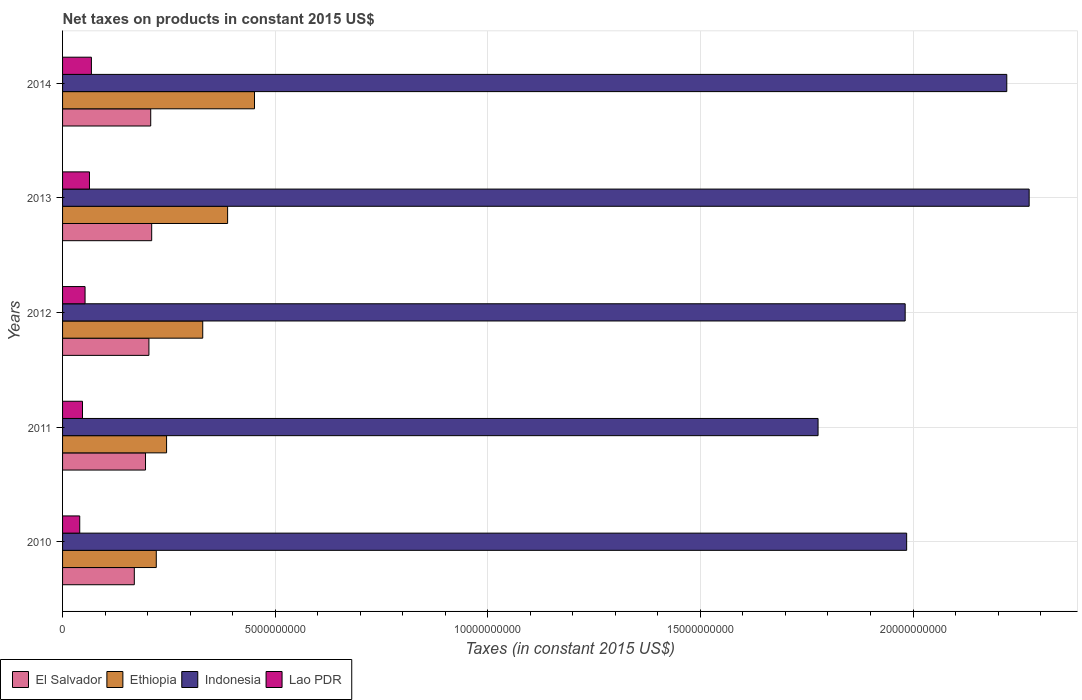How many different coloured bars are there?
Ensure brevity in your answer.  4. Are the number of bars per tick equal to the number of legend labels?
Keep it short and to the point. Yes. In how many cases, is the number of bars for a given year not equal to the number of legend labels?
Your response must be concise. 0. What is the net taxes on products in Indonesia in 2012?
Make the answer very short. 1.98e+1. Across all years, what is the maximum net taxes on products in El Salvador?
Ensure brevity in your answer.  2.10e+09. Across all years, what is the minimum net taxes on products in Lao PDR?
Your response must be concise. 4.04e+08. In which year was the net taxes on products in Indonesia maximum?
Your answer should be compact. 2013. In which year was the net taxes on products in Indonesia minimum?
Make the answer very short. 2011. What is the total net taxes on products in Lao PDR in the graph?
Keep it short and to the point. 2.71e+09. What is the difference between the net taxes on products in Lao PDR in 2010 and that in 2013?
Provide a short and direct response. -2.29e+08. What is the difference between the net taxes on products in El Salvador in 2011 and the net taxes on products in Ethiopia in 2013?
Ensure brevity in your answer.  -1.93e+09. What is the average net taxes on products in Ethiopia per year?
Ensure brevity in your answer.  3.27e+09. In the year 2010, what is the difference between the net taxes on products in Ethiopia and net taxes on products in Lao PDR?
Provide a short and direct response. 1.80e+09. In how many years, is the net taxes on products in Indonesia greater than 14000000000 US$?
Your response must be concise. 5. What is the ratio of the net taxes on products in El Salvador in 2011 to that in 2013?
Give a very brief answer. 0.93. What is the difference between the highest and the second highest net taxes on products in Indonesia?
Your answer should be very brief. 5.26e+08. What is the difference between the highest and the lowest net taxes on products in Ethiopia?
Provide a short and direct response. 2.31e+09. In how many years, is the net taxes on products in Lao PDR greater than the average net taxes on products in Lao PDR taken over all years?
Make the answer very short. 2. Is it the case that in every year, the sum of the net taxes on products in Ethiopia and net taxes on products in Indonesia is greater than the sum of net taxes on products in Lao PDR and net taxes on products in El Salvador?
Give a very brief answer. Yes. What does the 1st bar from the top in 2012 represents?
Ensure brevity in your answer.  Lao PDR. What does the 4th bar from the bottom in 2010 represents?
Provide a short and direct response. Lao PDR. Is it the case that in every year, the sum of the net taxes on products in Ethiopia and net taxes on products in Indonesia is greater than the net taxes on products in Lao PDR?
Provide a short and direct response. Yes. How many years are there in the graph?
Your answer should be compact. 5. Are the values on the major ticks of X-axis written in scientific E-notation?
Offer a very short reply. No. Does the graph contain grids?
Your answer should be compact. Yes. How many legend labels are there?
Provide a short and direct response. 4. What is the title of the graph?
Your answer should be very brief. Net taxes on products in constant 2015 US$. Does "Equatorial Guinea" appear as one of the legend labels in the graph?
Offer a terse response. No. What is the label or title of the X-axis?
Provide a short and direct response. Taxes (in constant 2015 US$). What is the label or title of the Y-axis?
Offer a very short reply. Years. What is the Taxes (in constant 2015 US$) of El Salvador in 2010?
Make the answer very short. 1.69e+09. What is the Taxes (in constant 2015 US$) in Ethiopia in 2010?
Make the answer very short. 2.20e+09. What is the Taxes (in constant 2015 US$) in Indonesia in 2010?
Provide a short and direct response. 1.99e+1. What is the Taxes (in constant 2015 US$) in Lao PDR in 2010?
Your answer should be compact. 4.04e+08. What is the Taxes (in constant 2015 US$) in El Salvador in 2011?
Your answer should be very brief. 1.95e+09. What is the Taxes (in constant 2015 US$) of Ethiopia in 2011?
Provide a succinct answer. 2.45e+09. What is the Taxes (in constant 2015 US$) of Indonesia in 2011?
Make the answer very short. 1.78e+1. What is the Taxes (in constant 2015 US$) of Lao PDR in 2011?
Your response must be concise. 4.69e+08. What is the Taxes (in constant 2015 US$) of El Salvador in 2012?
Provide a succinct answer. 2.03e+09. What is the Taxes (in constant 2015 US$) in Ethiopia in 2012?
Keep it short and to the point. 3.30e+09. What is the Taxes (in constant 2015 US$) of Indonesia in 2012?
Keep it short and to the point. 1.98e+1. What is the Taxes (in constant 2015 US$) in Lao PDR in 2012?
Offer a terse response. 5.29e+08. What is the Taxes (in constant 2015 US$) in El Salvador in 2013?
Make the answer very short. 2.10e+09. What is the Taxes (in constant 2015 US$) in Ethiopia in 2013?
Offer a very short reply. 3.88e+09. What is the Taxes (in constant 2015 US$) of Indonesia in 2013?
Provide a short and direct response. 2.27e+1. What is the Taxes (in constant 2015 US$) in Lao PDR in 2013?
Provide a short and direct response. 6.33e+08. What is the Taxes (in constant 2015 US$) of El Salvador in 2014?
Keep it short and to the point. 2.07e+09. What is the Taxes (in constant 2015 US$) of Ethiopia in 2014?
Offer a terse response. 4.51e+09. What is the Taxes (in constant 2015 US$) of Indonesia in 2014?
Your answer should be compact. 2.22e+1. What is the Taxes (in constant 2015 US$) in Lao PDR in 2014?
Ensure brevity in your answer.  6.78e+08. Across all years, what is the maximum Taxes (in constant 2015 US$) in El Salvador?
Provide a short and direct response. 2.10e+09. Across all years, what is the maximum Taxes (in constant 2015 US$) of Ethiopia?
Provide a short and direct response. 4.51e+09. Across all years, what is the maximum Taxes (in constant 2015 US$) in Indonesia?
Your answer should be very brief. 2.27e+1. Across all years, what is the maximum Taxes (in constant 2015 US$) in Lao PDR?
Offer a very short reply. 6.78e+08. Across all years, what is the minimum Taxes (in constant 2015 US$) in El Salvador?
Keep it short and to the point. 1.69e+09. Across all years, what is the minimum Taxes (in constant 2015 US$) of Ethiopia?
Provide a short and direct response. 2.20e+09. Across all years, what is the minimum Taxes (in constant 2015 US$) in Indonesia?
Ensure brevity in your answer.  1.78e+1. Across all years, what is the minimum Taxes (in constant 2015 US$) in Lao PDR?
Offer a very short reply. 4.04e+08. What is the total Taxes (in constant 2015 US$) of El Salvador in the graph?
Provide a short and direct response. 9.84e+09. What is the total Taxes (in constant 2015 US$) in Ethiopia in the graph?
Offer a very short reply. 1.63e+1. What is the total Taxes (in constant 2015 US$) in Indonesia in the graph?
Your response must be concise. 1.02e+11. What is the total Taxes (in constant 2015 US$) of Lao PDR in the graph?
Your answer should be compact. 2.71e+09. What is the difference between the Taxes (in constant 2015 US$) in El Salvador in 2010 and that in 2011?
Your response must be concise. -2.64e+08. What is the difference between the Taxes (in constant 2015 US$) of Ethiopia in 2010 and that in 2011?
Your answer should be very brief. -2.42e+08. What is the difference between the Taxes (in constant 2015 US$) in Indonesia in 2010 and that in 2011?
Provide a short and direct response. 2.08e+09. What is the difference between the Taxes (in constant 2015 US$) of Lao PDR in 2010 and that in 2011?
Provide a short and direct response. -6.51e+07. What is the difference between the Taxes (in constant 2015 US$) of El Salvador in 2010 and that in 2012?
Ensure brevity in your answer.  -3.44e+08. What is the difference between the Taxes (in constant 2015 US$) in Ethiopia in 2010 and that in 2012?
Offer a very short reply. -1.09e+09. What is the difference between the Taxes (in constant 2015 US$) of Indonesia in 2010 and that in 2012?
Ensure brevity in your answer.  3.49e+07. What is the difference between the Taxes (in constant 2015 US$) in Lao PDR in 2010 and that in 2012?
Your answer should be very brief. -1.25e+08. What is the difference between the Taxes (in constant 2015 US$) in El Salvador in 2010 and that in 2013?
Provide a succinct answer. -4.09e+08. What is the difference between the Taxes (in constant 2015 US$) of Ethiopia in 2010 and that in 2013?
Make the answer very short. -1.68e+09. What is the difference between the Taxes (in constant 2015 US$) in Indonesia in 2010 and that in 2013?
Ensure brevity in your answer.  -2.88e+09. What is the difference between the Taxes (in constant 2015 US$) in Lao PDR in 2010 and that in 2013?
Make the answer very short. -2.29e+08. What is the difference between the Taxes (in constant 2015 US$) of El Salvador in 2010 and that in 2014?
Provide a succinct answer. -3.86e+08. What is the difference between the Taxes (in constant 2015 US$) in Ethiopia in 2010 and that in 2014?
Make the answer very short. -2.31e+09. What is the difference between the Taxes (in constant 2015 US$) of Indonesia in 2010 and that in 2014?
Offer a very short reply. -2.35e+09. What is the difference between the Taxes (in constant 2015 US$) of Lao PDR in 2010 and that in 2014?
Give a very brief answer. -2.74e+08. What is the difference between the Taxes (in constant 2015 US$) of El Salvador in 2011 and that in 2012?
Offer a terse response. -8.00e+07. What is the difference between the Taxes (in constant 2015 US$) in Ethiopia in 2011 and that in 2012?
Give a very brief answer. -8.50e+08. What is the difference between the Taxes (in constant 2015 US$) of Indonesia in 2011 and that in 2012?
Offer a terse response. -2.05e+09. What is the difference between the Taxes (in constant 2015 US$) of Lao PDR in 2011 and that in 2012?
Your answer should be compact. -6.02e+07. What is the difference between the Taxes (in constant 2015 US$) in El Salvador in 2011 and that in 2013?
Make the answer very short. -1.45e+08. What is the difference between the Taxes (in constant 2015 US$) of Ethiopia in 2011 and that in 2013?
Provide a succinct answer. -1.44e+09. What is the difference between the Taxes (in constant 2015 US$) of Indonesia in 2011 and that in 2013?
Provide a succinct answer. -4.96e+09. What is the difference between the Taxes (in constant 2015 US$) of Lao PDR in 2011 and that in 2013?
Offer a very short reply. -1.64e+08. What is the difference between the Taxes (in constant 2015 US$) in El Salvador in 2011 and that in 2014?
Provide a succinct answer. -1.23e+08. What is the difference between the Taxes (in constant 2015 US$) of Ethiopia in 2011 and that in 2014?
Provide a succinct answer. -2.07e+09. What is the difference between the Taxes (in constant 2015 US$) in Indonesia in 2011 and that in 2014?
Make the answer very short. -4.44e+09. What is the difference between the Taxes (in constant 2015 US$) in Lao PDR in 2011 and that in 2014?
Offer a terse response. -2.09e+08. What is the difference between the Taxes (in constant 2015 US$) of El Salvador in 2012 and that in 2013?
Your answer should be very brief. -6.53e+07. What is the difference between the Taxes (in constant 2015 US$) in Ethiopia in 2012 and that in 2013?
Keep it short and to the point. -5.85e+08. What is the difference between the Taxes (in constant 2015 US$) in Indonesia in 2012 and that in 2013?
Make the answer very short. -2.92e+09. What is the difference between the Taxes (in constant 2015 US$) in Lao PDR in 2012 and that in 2013?
Ensure brevity in your answer.  -1.04e+08. What is the difference between the Taxes (in constant 2015 US$) of El Salvador in 2012 and that in 2014?
Offer a very short reply. -4.26e+07. What is the difference between the Taxes (in constant 2015 US$) in Ethiopia in 2012 and that in 2014?
Provide a succinct answer. -1.22e+09. What is the difference between the Taxes (in constant 2015 US$) in Indonesia in 2012 and that in 2014?
Offer a terse response. -2.39e+09. What is the difference between the Taxes (in constant 2015 US$) of Lao PDR in 2012 and that in 2014?
Ensure brevity in your answer.  -1.49e+08. What is the difference between the Taxes (in constant 2015 US$) of El Salvador in 2013 and that in 2014?
Offer a terse response. 2.27e+07. What is the difference between the Taxes (in constant 2015 US$) of Ethiopia in 2013 and that in 2014?
Give a very brief answer. -6.32e+08. What is the difference between the Taxes (in constant 2015 US$) of Indonesia in 2013 and that in 2014?
Offer a terse response. 5.26e+08. What is the difference between the Taxes (in constant 2015 US$) in Lao PDR in 2013 and that in 2014?
Offer a terse response. -4.55e+07. What is the difference between the Taxes (in constant 2015 US$) in El Salvador in 2010 and the Taxes (in constant 2015 US$) in Ethiopia in 2011?
Provide a succinct answer. -7.59e+08. What is the difference between the Taxes (in constant 2015 US$) in El Salvador in 2010 and the Taxes (in constant 2015 US$) in Indonesia in 2011?
Provide a succinct answer. -1.61e+1. What is the difference between the Taxes (in constant 2015 US$) of El Salvador in 2010 and the Taxes (in constant 2015 US$) of Lao PDR in 2011?
Offer a very short reply. 1.22e+09. What is the difference between the Taxes (in constant 2015 US$) of Ethiopia in 2010 and the Taxes (in constant 2015 US$) of Indonesia in 2011?
Give a very brief answer. -1.56e+1. What is the difference between the Taxes (in constant 2015 US$) of Ethiopia in 2010 and the Taxes (in constant 2015 US$) of Lao PDR in 2011?
Your answer should be very brief. 1.74e+09. What is the difference between the Taxes (in constant 2015 US$) of Indonesia in 2010 and the Taxes (in constant 2015 US$) of Lao PDR in 2011?
Your answer should be compact. 1.94e+1. What is the difference between the Taxes (in constant 2015 US$) in El Salvador in 2010 and the Taxes (in constant 2015 US$) in Ethiopia in 2012?
Offer a terse response. -1.61e+09. What is the difference between the Taxes (in constant 2015 US$) of El Salvador in 2010 and the Taxes (in constant 2015 US$) of Indonesia in 2012?
Give a very brief answer. -1.81e+1. What is the difference between the Taxes (in constant 2015 US$) in El Salvador in 2010 and the Taxes (in constant 2015 US$) in Lao PDR in 2012?
Provide a succinct answer. 1.16e+09. What is the difference between the Taxes (in constant 2015 US$) of Ethiopia in 2010 and the Taxes (in constant 2015 US$) of Indonesia in 2012?
Your answer should be very brief. -1.76e+1. What is the difference between the Taxes (in constant 2015 US$) of Ethiopia in 2010 and the Taxes (in constant 2015 US$) of Lao PDR in 2012?
Provide a short and direct response. 1.67e+09. What is the difference between the Taxes (in constant 2015 US$) in Indonesia in 2010 and the Taxes (in constant 2015 US$) in Lao PDR in 2012?
Your answer should be compact. 1.93e+1. What is the difference between the Taxes (in constant 2015 US$) of El Salvador in 2010 and the Taxes (in constant 2015 US$) of Ethiopia in 2013?
Offer a terse response. -2.19e+09. What is the difference between the Taxes (in constant 2015 US$) of El Salvador in 2010 and the Taxes (in constant 2015 US$) of Indonesia in 2013?
Your response must be concise. -2.10e+1. What is the difference between the Taxes (in constant 2015 US$) of El Salvador in 2010 and the Taxes (in constant 2015 US$) of Lao PDR in 2013?
Provide a succinct answer. 1.05e+09. What is the difference between the Taxes (in constant 2015 US$) in Ethiopia in 2010 and the Taxes (in constant 2015 US$) in Indonesia in 2013?
Make the answer very short. -2.05e+1. What is the difference between the Taxes (in constant 2015 US$) of Ethiopia in 2010 and the Taxes (in constant 2015 US$) of Lao PDR in 2013?
Offer a terse response. 1.57e+09. What is the difference between the Taxes (in constant 2015 US$) in Indonesia in 2010 and the Taxes (in constant 2015 US$) in Lao PDR in 2013?
Offer a terse response. 1.92e+1. What is the difference between the Taxes (in constant 2015 US$) of El Salvador in 2010 and the Taxes (in constant 2015 US$) of Ethiopia in 2014?
Your answer should be compact. -2.83e+09. What is the difference between the Taxes (in constant 2015 US$) in El Salvador in 2010 and the Taxes (in constant 2015 US$) in Indonesia in 2014?
Keep it short and to the point. -2.05e+1. What is the difference between the Taxes (in constant 2015 US$) in El Salvador in 2010 and the Taxes (in constant 2015 US$) in Lao PDR in 2014?
Offer a very short reply. 1.01e+09. What is the difference between the Taxes (in constant 2015 US$) of Ethiopia in 2010 and the Taxes (in constant 2015 US$) of Indonesia in 2014?
Offer a very short reply. -2.00e+1. What is the difference between the Taxes (in constant 2015 US$) of Ethiopia in 2010 and the Taxes (in constant 2015 US$) of Lao PDR in 2014?
Give a very brief answer. 1.53e+09. What is the difference between the Taxes (in constant 2015 US$) of Indonesia in 2010 and the Taxes (in constant 2015 US$) of Lao PDR in 2014?
Make the answer very short. 1.92e+1. What is the difference between the Taxes (in constant 2015 US$) in El Salvador in 2011 and the Taxes (in constant 2015 US$) in Ethiopia in 2012?
Offer a very short reply. -1.35e+09. What is the difference between the Taxes (in constant 2015 US$) in El Salvador in 2011 and the Taxes (in constant 2015 US$) in Indonesia in 2012?
Your response must be concise. -1.79e+1. What is the difference between the Taxes (in constant 2015 US$) of El Salvador in 2011 and the Taxes (in constant 2015 US$) of Lao PDR in 2012?
Your answer should be compact. 1.42e+09. What is the difference between the Taxes (in constant 2015 US$) in Ethiopia in 2011 and the Taxes (in constant 2015 US$) in Indonesia in 2012?
Your answer should be compact. -1.74e+1. What is the difference between the Taxes (in constant 2015 US$) of Ethiopia in 2011 and the Taxes (in constant 2015 US$) of Lao PDR in 2012?
Make the answer very short. 1.92e+09. What is the difference between the Taxes (in constant 2015 US$) of Indonesia in 2011 and the Taxes (in constant 2015 US$) of Lao PDR in 2012?
Give a very brief answer. 1.72e+1. What is the difference between the Taxes (in constant 2015 US$) in El Salvador in 2011 and the Taxes (in constant 2015 US$) in Ethiopia in 2013?
Your answer should be compact. -1.93e+09. What is the difference between the Taxes (in constant 2015 US$) in El Salvador in 2011 and the Taxes (in constant 2015 US$) in Indonesia in 2013?
Keep it short and to the point. -2.08e+1. What is the difference between the Taxes (in constant 2015 US$) in El Salvador in 2011 and the Taxes (in constant 2015 US$) in Lao PDR in 2013?
Your answer should be very brief. 1.32e+09. What is the difference between the Taxes (in constant 2015 US$) of Ethiopia in 2011 and the Taxes (in constant 2015 US$) of Indonesia in 2013?
Ensure brevity in your answer.  -2.03e+1. What is the difference between the Taxes (in constant 2015 US$) in Ethiopia in 2011 and the Taxes (in constant 2015 US$) in Lao PDR in 2013?
Offer a terse response. 1.81e+09. What is the difference between the Taxes (in constant 2015 US$) of Indonesia in 2011 and the Taxes (in constant 2015 US$) of Lao PDR in 2013?
Ensure brevity in your answer.  1.71e+1. What is the difference between the Taxes (in constant 2015 US$) of El Salvador in 2011 and the Taxes (in constant 2015 US$) of Ethiopia in 2014?
Your answer should be compact. -2.56e+09. What is the difference between the Taxes (in constant 2015 US$) in El Salvador in 2011 and the Taxes (in constant 2015 US$) in Indonesia in 2014?
Ensure brevity in your answer.  -2.03e+1. What is the difference between the Taxes (in constant 2015 US$) in El Salvador in 2011 and the Taxes (in constant 2015 US$) in Lao PDR in 2014?
Your answer should be compact. 1.27e+09. What is the difference between the Taxes (in constant 2015 US$) of Ethiopia in 2011 and the Taxes (in constant 2015 US$) of Indonesia in 2014?
Give a very brief answer. -1.98e+1. What is the difference between the Taxes (in constant 2015 US$) of Ethiopia in 2011 and the Taxes (in constant 2015 US$) of Lao PDR in 2014?
Offer a terse response. 1.77e+09. What is the difference between the Taxes (in constant 2015 US$) of Indonesia in 2011 and the Taxes (in constant 2015 US$) of Lao PDR in 2014?
Make the answer very short. 1.71e+1. What is the difference between the Taxes (in constant 2015 US$) of El Salvador in 2012 and the Taxes (in constant 2015 US$) of Ethiopia in 2013?
Your response must be concise. -1.85e+09. What is the difference between the Taxes (in constant 2015 US$) of El Salvador in 2012 and the Taxes (in constant 2015 US$) of Indonesia in 2013?
Your answer should be very brief. -2.07e+1. What is the difference between the Taxes (in constant 2015 US$) in El Salvador in 2012 and the Taxes (in constant 2015 US$) in Lao PDR in 2013?
Make the answer very short. 1.40e+09. What is the difference between the Taxes (in constant 2015 US$) in Ethiopia in 2012 and the Taxes (in constant 2015 US$) in Indonesia in 2013?
Your response must be concise. -1.94e+1. What is the difference between the Taxes (in constant 2015 US$) in Ethiopia in 2012 and the Taxes (in constant 2015 US$) in Lao PDR in 2013?
Offer a very short reply. 2.66e+09. What is the difference between the Taxes (in constant 2015 US$) of Indonesia in 2012 and the Taxes (in constant 2015 US$) of Lao PDR in 2013?
Keep it short and to the point. 1.92e+1. What is the difference between the Taxes (in constant 2015 US$) in El Salvador in 2012 and the Taxes (in constant 2015 US$) in Ethiopia in 2014?
Offer a terse response. -2.48e+09. What is the difference between the Taxes (in constant 2015 US$) in El Salvador in 2012 and the Taxes (in constant 2015 US$) in Indonesia in 2014?
Make the answer very short. -2.02e+1. What is the difference between the Taxes (in constant 2015 US$) in El Salvador in 2012 and the Taxes (in constant 2015 US$) in Lao PDR in 2014?
Make the answer very short. 1.35e+09. What is the difference between the Taxes (in constant 2015 US$) in Ethiopia in 2012 and the Taxes (in constant 2015 US$) in Indonesia in 2014?
Your answer should be very brief. -1.89e+1. What is the difference between the Taxes (in constant 2015 US$) in Ethiopia in 2012 and the Taxes (in constant 2015 US$) in Lao PDR in 2014?
Your response must be concise. 2.62e+09. What is the difference between the Taxes (in constant 2015 US$) of Indonesia in 2012 and the Taxes (in constant 2015 US$) of Lao PDR in 2014?
Your response must be concise. 1.91e+1. What is the difference between the Taxes (in constant 2015 US$) in El Salvador in 2013 and the Taxes (in constant 2015 US$) in Ethiopia in 2014?
Provide a short and direct response. -2.42e+09. What is the difference between the Taxes (in constant 2015 US$) of El Salvador in 2013 and the Taxes (in constant 2015 US$) of Indonesia in 2014?
Ensure brevity in your answer.  -2.01e+1. What is the difference between the Taxes (in constant 2015 US$) in El Salvador in 2013 and the Taxes (in constant 2015 US$) in Lao PDR in 2014?
Your response must be concise. 1.42e+09. What is the difference between the Taxes (in constant 2015 US$) of Ethiopia in 2013 and the Taxes (in constant 2015 US$) of Indonesia in 2014?
Make the answer very short. -1.83e+1. What is the difference between the Taxes (in constant 2015 US$) of Ethiopia in 2013 and the Taxes (in constant 2015 US$) of Lao PDR in 2014?
Offer a terse response. 3.20e+09. What is the difference between the Taxes (in constant 2015 US$) of Indonesia in 2013 and the Taxes (in constant 2015 US$) of Lao PDR in 2014?
Keep it short and to the point. 2.21e+1. What is the average Taxes (in constant 2015 US$) of El Salvador per year?
Keep it short and to the point. 1.97e+09. What is the average Taxes (in constant 2015 US$) in Ethiopia per year?
Provide a short and direct response. 3.27e+09. What is the average Taxes (in constant 2015 US$) of Indonesia per year?
Offer a very short reply. 2.05e+1. What is the average Taxes (in constant 2015 US$) of Lao PDR per year?
Your response must be concise. 5.43e+08. In the year 2010, what is the difference between the Taxes (in constant 2015 US$) of El Salvador and Taxes (in constant 2015 US$) of Ethiopia?
Offer a terse response. -5.17e+08. In the year 2010, what is the difference between the Taxes (in constant 2015 US$) in El Salvador and Taxes (in constant 2015 US$) in Indonesia?
Your answer should be very brief. -1.82e+1. In the year 2010, what is the difference between the Taxes (in constant 2015 US$) of El Salvador and Taxes (in constant 2015 US$) of Lao PDR?
Provide a short and direct response. 1.28e+09. In the year 2010, what is the difference between the Taxes (in constant 2015 US$) in Ethiopia and Taxes (in constant 2015 US$) in Indonesia?
Make the answer very short. -1.76e+1. In the year 2010, what is the difference between the Taxes (in constant 2015 US$) of Ethiopia and Taxes (in constant 2015 US$) of Lao PDR?
Give a very brief answer. 1.80e+09. In the year 2010, what is the difference between the Taxes (in constant 2015 US$) of Indonesia and Taxes (in constant 2015 US$) of Lao PDR?
Offer a terse response. 1.94e+1. In the year 2011, what is the difference between the Taxes (in constant 2015 US$) of El Salvador and Taxes (in constant 2015 US$) of Ethiopia?
Your response must be concise. -4.95e+08. In the year 2011, what is the difference between the Taxes (in constant 2015 US$) of El Salvador and Taxes (in constant 2015 US$) of Indonesia?
Provide a short and direct response. -1.58e+1. In the year 2011, what is the difference between the Taxes (in constant 2015 US$) of El Salvador and Taxes (in constant 2015 US$) of Lao PDR?
Your answer should be very brief. 1.48e+09. In the year 2011, what is the difference between the Taxes (in constant 2015 US$) in Ethiopia and Taxes (in constant 2015 US$) in Indonesia?
Keep it short and to the point. -1.53e+1. In the year 2011, what is the difference between the Taxes (in constant 2015 US$) of Ethiopia and Taxes (in constant 2015 US$) of Lao PDR?
Your answer should be very brief. 1.98e+09. In the year 2011, what is the difference between the Taxes (in constant 2015 US$) of Indonesia and Taxes (in constant 2015 US$) of Lao PDR?
Make the answer very short. 1.73e+1. In the year 2012, what is the difference between the Taxes (in constant 2015 US$) in El Salvador and Taxes (in constant 2015 US$) in Ethiopia?
Provide a short and direct response. -1.27e+09. In the year 2012, what is the difference between the Taxes (in constant 2015 US$) in El Salvador and Taxes (in constant 2015 US$) in Indonesia?
Give a very brief answer. -1.78e+1. In the year 2012, what is the difference between the Taxes (in constant 2015 US$) of El Salvador and Taxes (in constant 2015 US$) of Lao PDR?
Provide a succinct answer. 1.50e+09. In the year 2012, what is the difference between the Taxes (in constant 2015 US$) of Ethiopia and Taxes (in constant 2015 US$) of Indonesia?
Offer a very short reply. -1.65e+1. In the year 2012, what is the difference between the Taxes (in constant 2015 US$) of Ethiopia and Taxes (in constant 2015 US$) of Lao PDR?
Offer a terse response. 2.77e+09. In the year 2012, what is the difference between the Taxes (in constant 2015 US$) of Indonesia and Taxes (in constant 2015 US$) of Lao PDR?
Offer a very short reply. 1.93e+1. In the year 2013, what is the difference between the Taxes (in constant 2015 US$) of El Salvador and Taxes (in constant 2015 US$) of Ethiopia?
Ensure brevity in your answer.  -1.79e+09. In the year 2013, what is the difference between the Taxes (in constant 2015 US$) in El Salvador and Taxes (in constant 2015 US$) in Indonesia?
Keep it short and to the point. -2.06e+1. In the year 2013, what is the difference between the Taxes (in constant 2015 US$) of El Salvador and Taxes (in constant 2015 US$) of Lao PDR?
Your response must be concise. 1.46e+09. In the year 2013, what is the difference between the Taxes (in constant 2015 US$) of Ethiopia and Taxes (in constant 2015 US$) of Indonesia?
Your answer should be compact. -1.89e+1. In the year 2013, what is the difference between the Taxes (in constant 2015 US$) in Ethiopia and Taxes (in constant 2015 US$) in Lao PDR?
Offer a very short reply. 3.25e+09. In the year 2013, what is the difference between the Taxes (in constant 2015 US$) of Indonesia and Taxes (in constant 2015 US$) of Lao PDR?
Your response must be concise. 2.21e+1. In the year 2014, what is the difference between the Taxes (in constant 2015 US$) of El Salvador and Taxes (in constant 2015 US$) of Ethiopia?
Offer a terse response. -2.44e+09. In the year 2014, what is the difference between the Taxes (in constant 2015 US$) of El Salvador and Taxes (in constant 2015 US$) of Indonesia?
Make the answer very short. -2.01e+1. In the year 2014, what is the difference between the Taxes (in constant 2015 US$) in El Salvador and Taxes (in constant 2015 US$) in Lao PDR?
Provide a short and direct response. 1.40e+09. In the year 2014, what is the difference between the Taxes (in constant 2015 US$) in Ethiopia and Taxes (in constant 2015 US$) in Indonesia?
Offer a terse response. -1.77e+1. In the year 2014, what is the difference between the Taxes (in constant 2015 US$) in Ethiopia and Taxes (in constant 2015 US$) in Lao PDR?
Make the answer very short. 3.84e+09. In the year 2014, what is the difference between the Taxes (in constant 2015 US$) of Indonesia and Taxes (in constant 2015 US$) of Lao PDR?
Make the answer very short. 2.15e+1. What is the ratio of the Taxes (in constant 2015 US$) of El Salvador in 2010 to that in 2011?
Provide a succinct answer. 0.86. What is the ratio of the Taxes (in constant 2015 US$) in Ethiopia in 2010 to that in 2011?
Give a very brief answer. 0.9. What is the ratio of the Taxes (in constant 2015 US$) in Indonesia in 2010 to that in 2011?
Ensure brevity in your answer.  1.12. What is the ratio of the Taxes (in constant 2015 US$) in Lao PDR in 2010 to that in 2011?
Your answer should be compact. 0.86. What is the ratio of the Taxes (in constant 2015 US$) of El Salvador in 2010 to that in 2012?
Provide a succinct answer. 0.83. What is the ratio of the Taxes (in constant 2015 US$) of Ethiopia in 2010 to that in 2012?
Your answer should be very brief. 0.67. What is the ratio of the Taxes (in constant 2015 US$) in Indonesia in 2010 to that in 2012?
Your answer should be very brief. 1. What is the ratio of the Taxes (in constant 2015 US$) in Lao PDR in 2010 to that in 2012?
Make the answer very short. 0.76. What is the ratio of the Taxes (in constant 2015 US$) in El Salvador in 2010 to that in 2013?
Provide a short and direct response. 0.81. What is the ratio of the Taxes (in constant 2015 US$) in Ethiopia in 2010 to that in 2013?
Your answer should be very brief. 0.57. What is the ratio of the Taxes (in constant 2015 US$) of Indonesia in 2010 to that in 2013?
Provide a short and direct response. 0.87. What is the ratio of the Taxes (in constant 2015 US$) of Lao PDR in 2010 to that in 2013?
Offer a terse response. 0.64. What is the ratio of the Taxes (in constant 2015 US$) of El Salvador in 2010 to that in 2014?
Your answer should be very brief. 0.81. What is the ratio of the Taxes (in constant 2015 US$) of Ethiopia in 2010 to that in 2014?
Offer a terse response. 0.49. What is the ratio of the Taxes (in constant 2015 US$) in Indonesia in 2010 to that in 2014?
Your answer should be compact. 0.89. What is the ratio of the Taxes (in constant 2015 US$) in Lao PDR in 2010 to that in 2014?
Your response must be concise. 0.6. What is the ratio of the Taxes (in constant 2015 US$) of El Salvador in 2011 to that in 2012?
Your answer should be compact. 0.96. What is the ratio of the Taxes (in constant 2015 US$) of Ethiopia in 2011 to that in 2012?
Give a very brief answer. 0.74. What is the ratio of the Taxes (in constant 2015 US$) in Indonesia in 2011 to that in 2012?
Your answer should be very brief. 0.9. What is the ratio of the Taxes (in constant 2015 US$) in Lao PDR in 2011 to that in 2012?
Your answer should be very brief. 0.89. What is the ratio of the Taxes (in constant 2015 US$) of El Salvador in 2011 to that in 2013?
Keep it short and to the point. 0.93. What is the ratio of the Taxes (in constant 2015 US$) in Ethiopia in 2011 to that in 2013?
Offer a very short reply. 0.63. What is the ratio of the Taxes (in constant 2015 US$) in Indonesia in 2011 to that in 2013?
Ensure brevity in your answer.  0.78. What is the ratio of the Taxes (in constant 2015 US$) in Lao PDR in 2011 to that in 2013?
Your answer should be very brief. 0.74. What is the ratio of the Taxes (in constant 2015 US$) of El Salvador in 2011 to that in 2014?
Provide a short and direct response. 0.94. What is the ratio of the Taxes (in constant 2015 US$) of Ethiopia in 2011 to that in 2014?
Make the answer very short. 0.54. What is the ratio of the Taxes (in constant 2015 US$) in Indonesia in 2011 to that in 2014?
Your answer should be compact. 0.8. What is the ratio of the Taxes (in constant 2015 US$) of Lao PDR in 2011 to that in 2014?
Offer a very short reply. 0.69. What is the ratio of the Taxes (in constant 2015 US$) in El Salvador in 2012 to that in 2013?
Make the answer very short. 0.97. What is the ratio of the Taxes (in constant 2015 US$) in Ethiopia in 2012 to that in 2013?
Your answer should be very brief. 0.85. What is the ratio of the Taxes (in constant 2015 US$) in Indonesia in 2012 to that in 2013?
Ensure brevity in your answer.  0.87. What is the ratio of the Taxes (in constant 2015 US$) in Lao PDR in 2012 to that in 2013?
Provide a succinct answer. 0.84. What is the ratio of the Taxes (in constant 2015 US$) in El Salvador in 2012 to that in 2014?
Ensure brevity in your answer.  0.98. What is the ratio of the Taxes (in constant 2015 US$) in Ethiopia in 2012 to that in 2014?
Ensure brevity in your answer.  0.73. What is the ratio of the Taxes (in constant 2015 US$) of Indonesia in 2012 to that in 2014?
Your response must be concise. 0.89. What is the ratio of the Taxes (in constant 2015 US$) of Lao PDR in 2012 to that in 2014?
Offer a terse response. 0.78. What is the ratio of the Taxes (in constant 2015 US$) in El Salvador in 2013 to that in 2014?
Offer a terse response. 1.01. What is the ratio of the Taxes (in constant 2015 US$) in Ethiopia in 2013 to that in 2014?
Offer a very short reply. 0.86. What is the ratio of the Taxes (in constant 2015 US$) in Indonesia in 2013 to that in 2014?
Make the answer very short. 1.02. What is the ratio of the Taxes (in constant 2015 US$) in Lao PDR in 2013 to that in 2014?
Provide a short and direct response. 0.93. What is the difference between the highest and the second highest Taxes (in constant 2015 US$) in El Salvador?
Make the answer very short. 2.27e+07. What is the difference between the highest and the second highest Taxes (in constant 2015 US$) in Ethiopia?
Provide a short and direct response. 6.32e+08. What is the difference between the highest and the second highest Taxes (in constant 2015 US$) of Indonesia?
Make the answer very short. 5.26e+08. What is the difference between the highest and the second highest Taxes (in constant 2015 US$) of Lao PDR?
Provide a short and direct response. 4.55e+07. What is the difference between the highest and the lowest Taxes (in constant 2015 US$) of El Salvador?
Your response must be concise. 4.09e+08. What is the difference between the highest and the lowest Taxes (in constant 2015 US$) of Ethiopia?
Your response must be concise. 2.31e+09. What is the difference between the highest and the lowest Taxes (in constant 2015 US$) of Indonesia?
Offer a very short reply. 4.96e+09. What is the difference between the highest and the lowest Taxes (in constant 2015 US$) of Lao PDR?
Keep it short and to the point. 2.74e+08. 